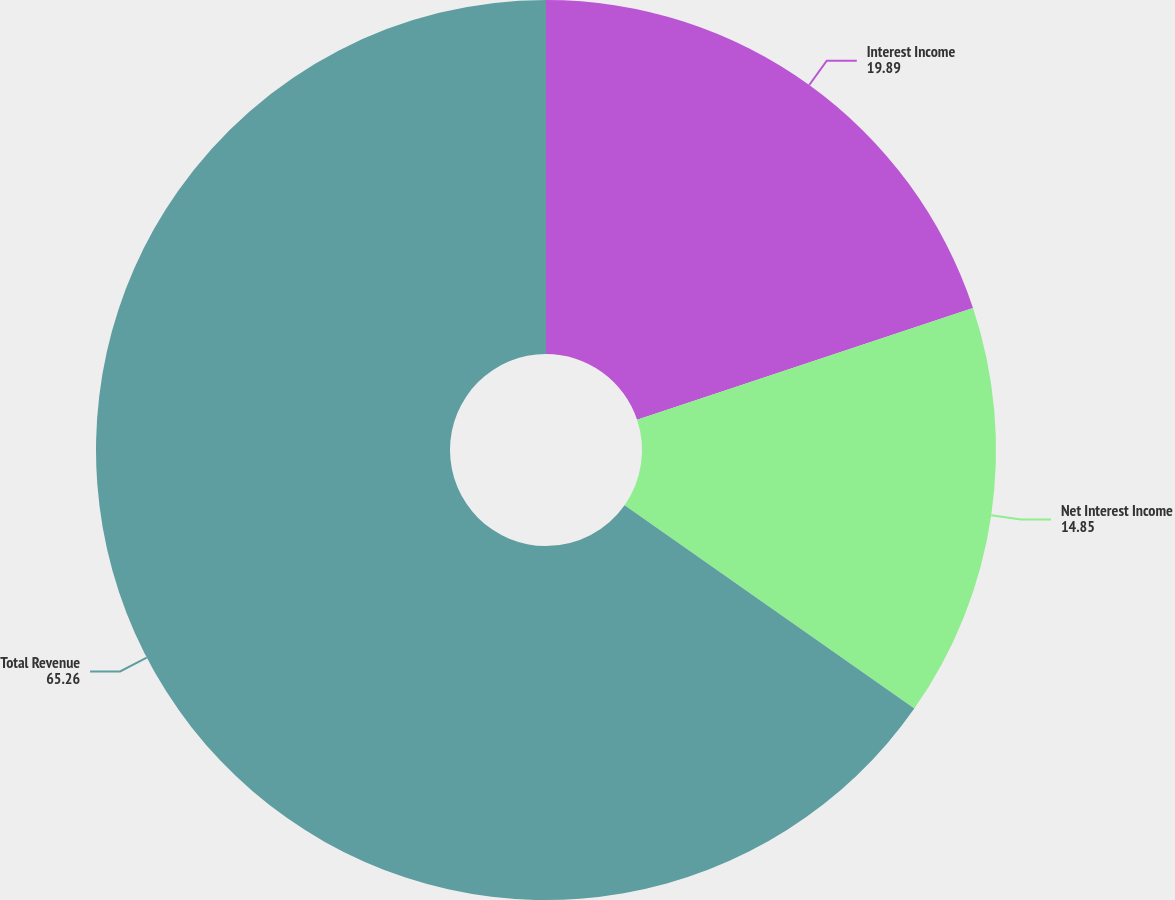Convert chart. <chart><loc_0><loc_0><loc_500><loc_500><pie_chart><fcel>Interest Income<fcel>Net Interest Income<fcel>Total Revenue<nl><fcel>19.89%<fcel>14.85%<fcel>65.26%<nl></chart> 